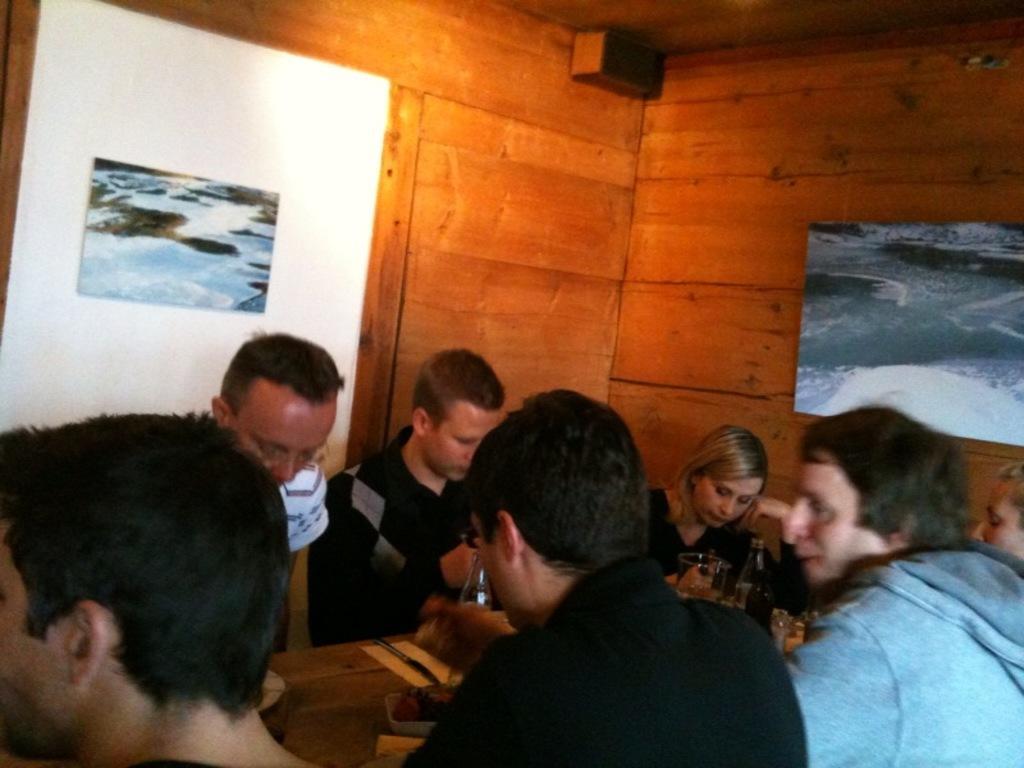How would you summarize this image in a sentence or two? In this image, there are group of people wearing clothes and sitting in front of the table. This table contains bottles. 